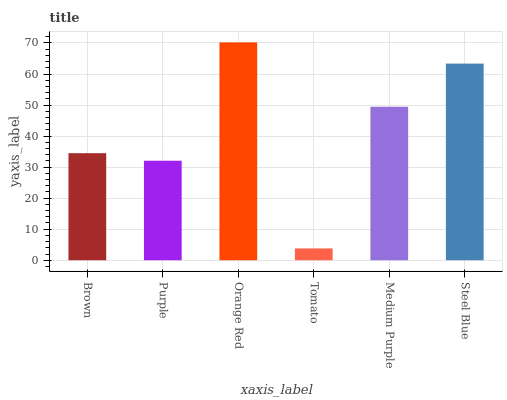Is Tomato the minimum?
Answer yes or no. Yes. Is Orange Red the maximum?
Answer yes or no. Yes. Is Purple the minimum?
Answer yes or no. No. Is Purple the maximum?
Answer yes or no. No. Is Brown greater than Purple?
Answer yes or no. Yes. Is Purple less than Brown?
Answer yes or no. Yes. Is Purple greater than Brown?
Answer yes or no. No. Is Brown less than Purple?
Answer yes or no. No. Is Medium Purple the high median?
Answer yes or no. Yes. Is Brown the low median?
Answer yes or no. Yes. Is Tomato the high median?
Answer yes or no. No. Is Purple the low median?
Answer yes or no. No. 